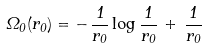<formula> <loc_0><loc_0><loc_500><loc_500>\Omega _ { 0 } ( r _ { 0 } ) = - \, \frac { 1 } { r _ { 0 } } \log \frac { 1 } { r _ { 0 } } \, + \, \frac { 1 } { r _ { 0 } }</formula> 